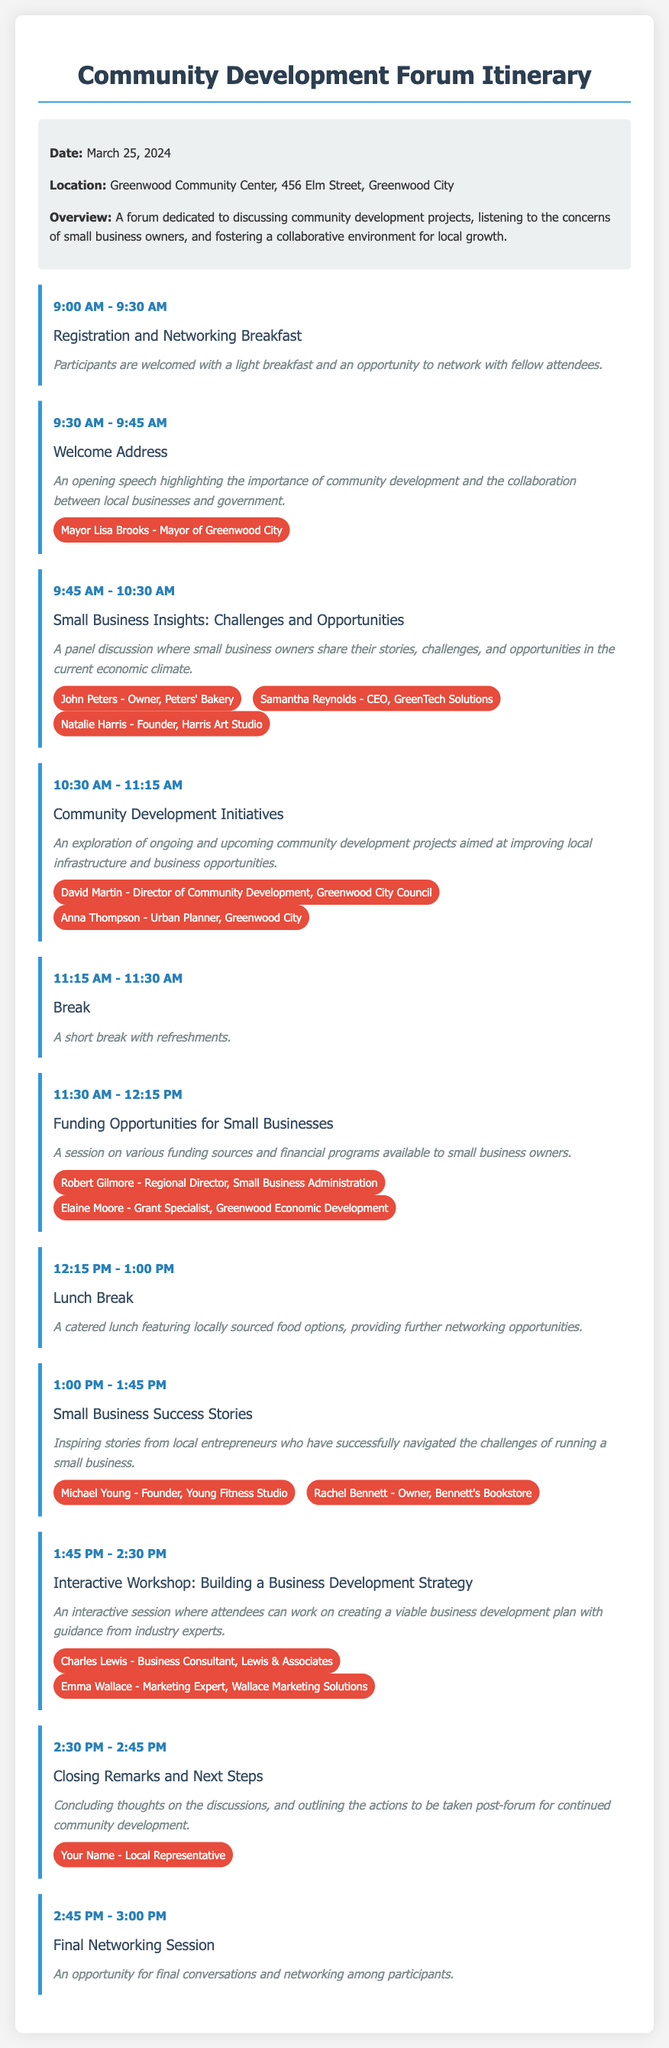What is the date of the forum? The date of the forum is clearly stated in the event information section.
Answer: March 25, 2024 Where is the forum located? The location of the forum is provided in the event information section.
Answer: Greenwood Community Center, 456 Elm Street, Greenwood City Who delivers the Welcome Address? The speaker for the Welcome Address is mentioned in the corresponding session details.
Answer: Mayor Lisa Brooks How long is the break scheduled for? The duration of the break can be inferred from the session times listed in the agenda section.
Answer: 15 minutes What session follows the lunch break? The agenda provides a sequential listing of sessions, allowing for identification of the session after lunch.
Answer: Small Business Success Stories Which session discusses funding opportunities? The title of the session focusing on funding opportunities is specified in the agenda.
Answer: Funding Opportunities for Small Businesses Who are the speakers for the interactive workshop? The speakers for the workshop are explicitly named in the relevant session of the agenda.
Answer: Charles Lewis, Emma Wallace What time does the final networking session start? The start time for the final networking session is directly provided in the agenda section.
Answer: 2:45 PM 